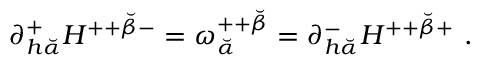Convert formula to latex. <formula><loc_0><loc_0><loc_500><loc_500>\partial _ { h { \breve { \alpha } } } ^ { + } H ^ { + + { \breve { \beta } } - } = \omega _ { \breve { \alpha } } ^ { + + { \breve { \beta } } } = \partial _ { h { \breve { \alpha } } } ^ { - } H ^ { + + { \breve { \beta } } + } \ .</formula> 